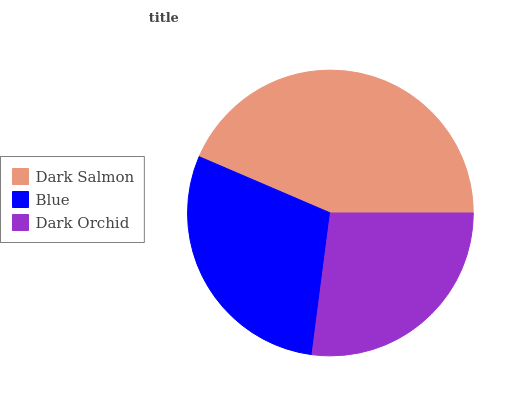Is Dark Orchid the minimum?
Answer yes or no. Yes. Is Dark Salmon the maximum?
Answer yes or no. Yes. Is Blue the minimum?
Answer yes or no. No. Is Blue the maximum?
Answer yes or no. No. Is Dark Salmon greater than Blue?
Answer yes or no. Yes. Is Blue less than Dark Salmon?
Answer yes or no. Yes. Is Blue greater than Dark Salmon?
Answer yes or no. No. Is Dark Salmon less than Blue?
Answer yes or no. No. Is Blue the high median?
Answer yes or no. Yes. Is Blue the low median?
Answer yes or no. Yes. Is Dark Salmon the high median?
Answer yes or no. No. Is Dark Orchid the low median?
Answer yes or no. No. 